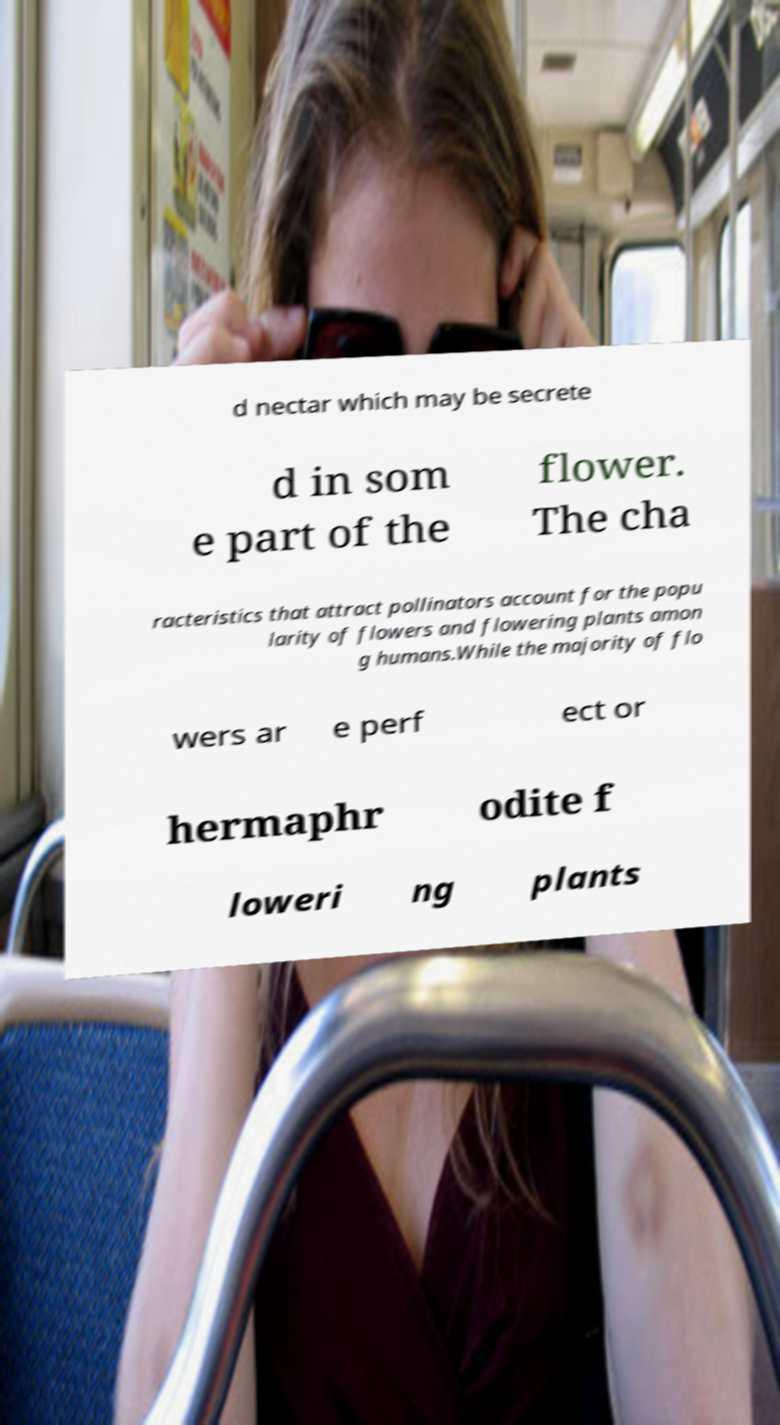Can you accurately transcribe the text from the provided image for me? d nectar which may be secrete d in som e part of the flower. The cha racteristics that attract pollinators account for the popu larity of flowers and flowering plants amon g humans.While the majority of flo wers ar e perf ect or hermaphr odite f loweri ng plants 